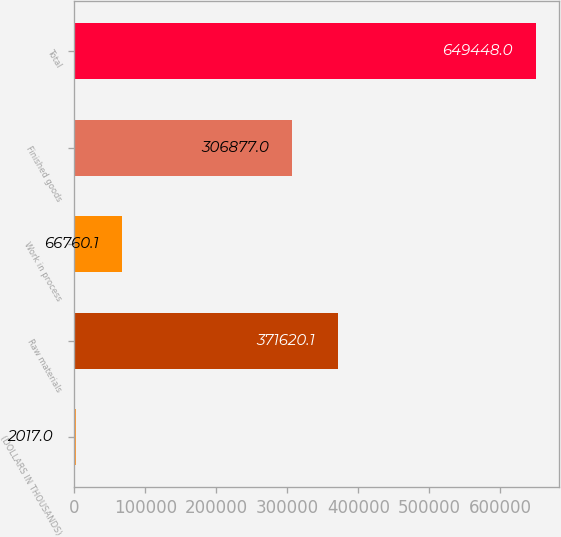Convert chart. <chart><loc_0><loc_0><loc_500><loc_500><bar_chart><fcel>(DOLLARS IN THOUSANDS)<fcel>Raw materials<fcel>Work in process<fcel>Finished goods<fcel>Total<nl><fcel>2017<fcel>371620<fcel>66760.1<fcel>306877<fcel>649448<nl></chart> 